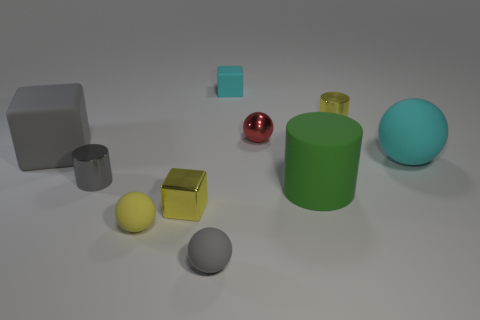Does the green matte cylinder have the same size as the gray matte block? Upon observing the image, the green matte cylinder and the gray matte block do indeed appear to share similar dimensions in height and width, suggesting that they might be of the same size visually. However, without precise measurements, it can't be confirmed if they are exactly identical in scale. 